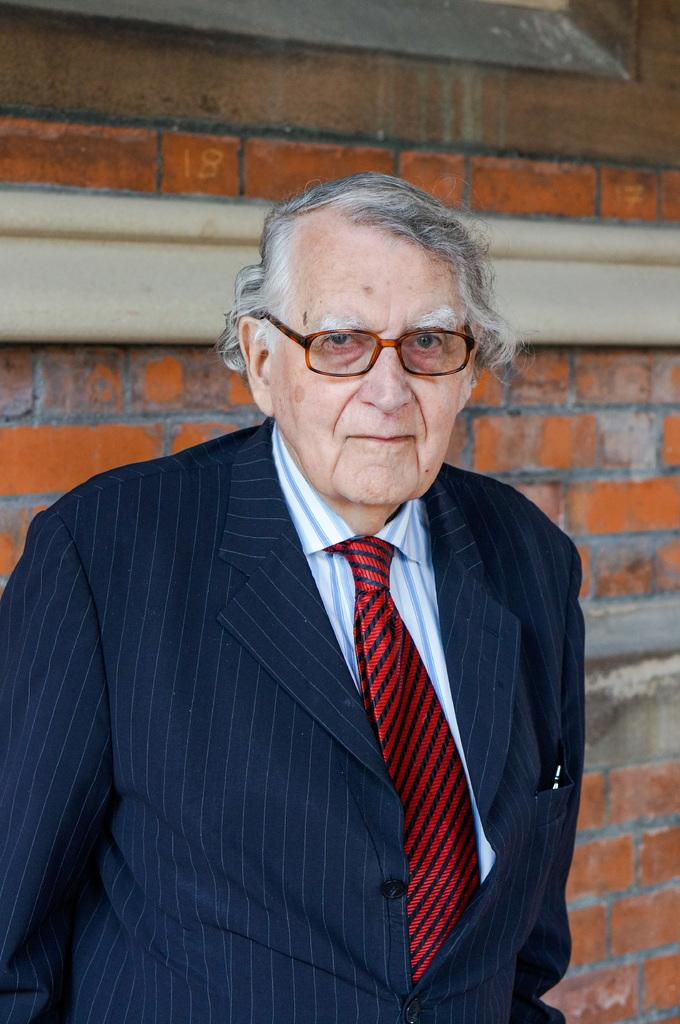What is the main subject of the image? There is a man standing in the image. Can you describe the background of the image? There is a wall in the background of the image. What type of pen is the man holding in the image? There is no pen visible in the image; the man is not holding anything. 